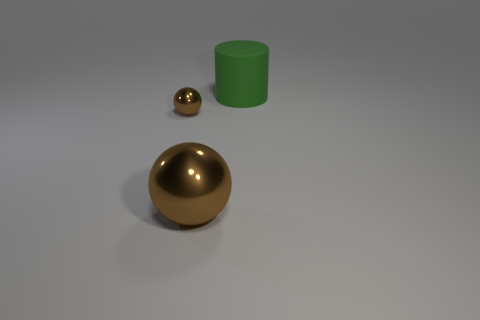Add 3 red metal cylinders. How many objects exist? 6 Subtract all balls. How many objects are left? 1 Add 2 tiny spheres. How many tiny spheres are left? 3 Add 2 cylinders. How many cylinders exist? 3 Subtract 0 blue cylinders. How many objects are left? 3 Subtract all blue balls. Subtract all cyan cylinders. How many balls are left? 2 Subtract all tiny brown rubber spheres. Subtract all big green objects. How many objects are left? 2 